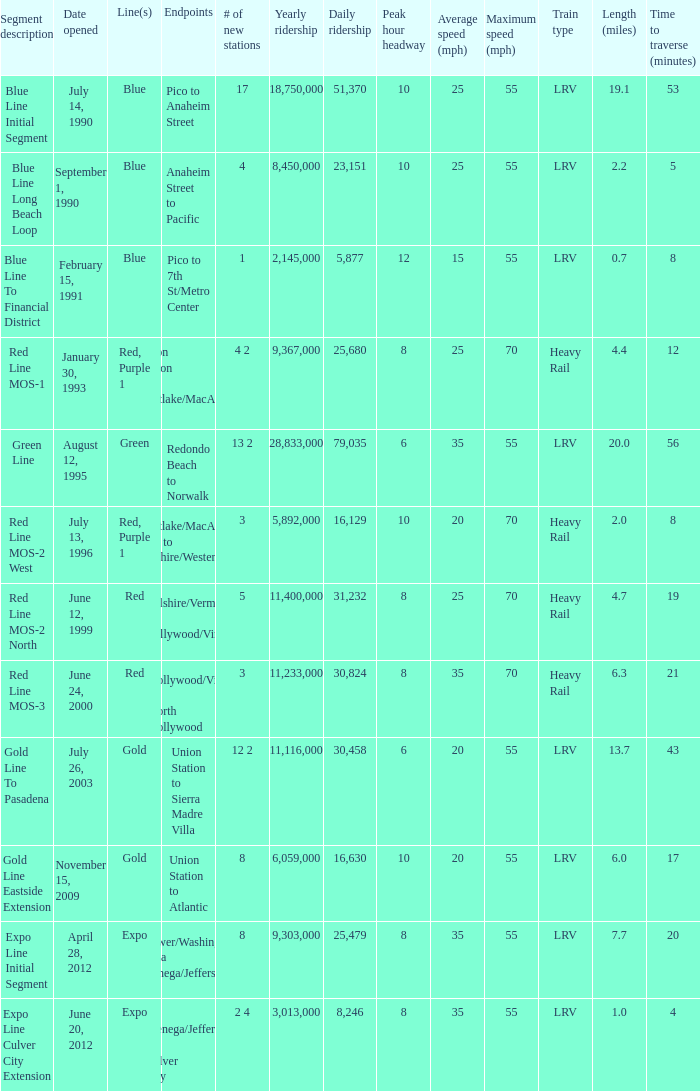How many lines have the segment description of red line mos-2 west? Red, Purple 1. 